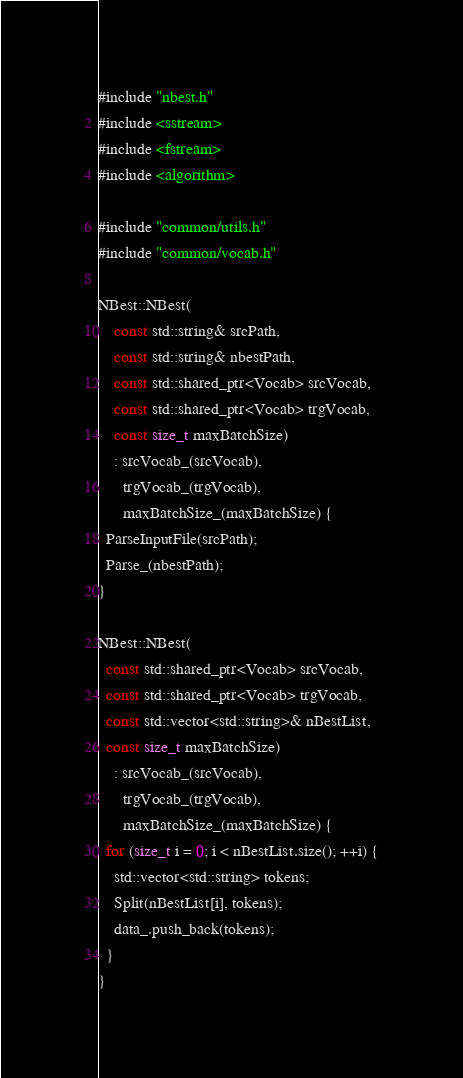<code> <loc_0><loc_0><loc_500><loc_500><_Cuda_>#include "nbest.h"
#include <sstream>
#include <fstream>
#include <algorithm>

#include "common/utils.h"
#include "common/vocab.h"

NBest::NBest(
    const std::string& srcPath,
    const std::string& nbestPath,
    const std::shared_ptr<Vocab> srcVocab,
    const std::shared_ptr<Vocab> trgVocab,
    const size_t maxBatchSize)
    : srcVocab_(srcVocab),
      trgVocab_(trgVocab),
      maxBatchSize_(maxBatchSize) {
  ParseInputFile(srcPath);
  Parse_(nbestPath);
}

NBest::NBest(
  const std::shared_ptr<Vocab> srcVocab,
  const std::shared_ptr<Vocab> trgVocab,
  const std::vector<std::string>& nBestList,
  const size_t maxBatchSize)
    : srcVocab_(srcVocab),
      trgVocab_(trgVocab),
      maxBatchSize_(maxBatchSize) {
  for (size_t i = 0; i < nBestList.size(); ++i) {
    std::vector<std::string> tokens;
    Split(nBestList[i], tokens);
    data_.push_back(tokens);
  }
}
</code> 